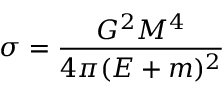<formula> <loc_0><loc_0><loc_500><loc_500>\sigma = \frac { G ^ { 2 } M ^ { 4 } } { 4 \pi ( E + m ) ^ { 2 } }</formula> 